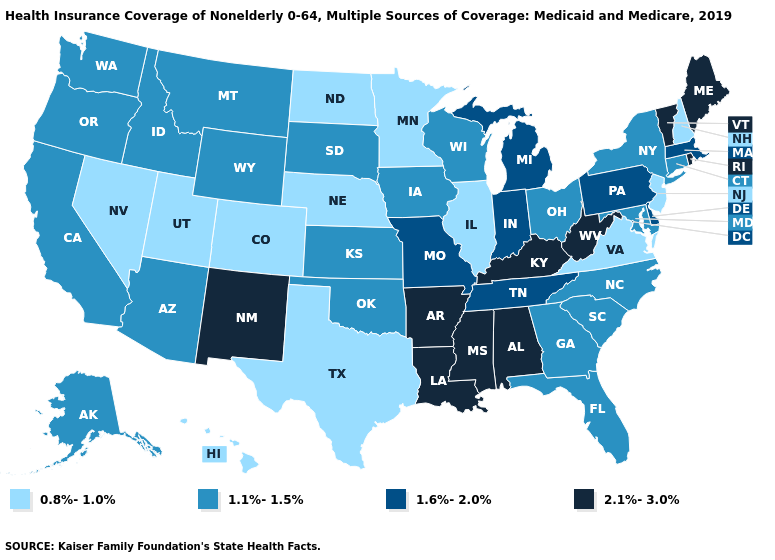What is the value of New Jersey?
Answer briefly. 0.8%-1.0%. Name the states that have a value in the range 0.8%-1.0%?
Keep it brief. Colorado, Hawaii, Illinois, Minnesota, Nebraska, Nevada, New Hampshire, New Jersey, North Dakota, Texas, Utah, Virginia. Does the map have missing data?
Quick response, please. No. Which states have the lowest value in the USA?
Answer briefly. Colorado, Hawaii, Illinois, Minnesota, Nebraska, Nevada, New Hampshire, New Jersey, North Dakota, Texas, Utah, Virginia. Does Missouri have a lower value than Texas?
Concise answer only. No. What is the value of New York?
Quick response, please. 1.1%-1.5%. Does Iowa have the highest value in the MidWest?
Concise answer only. No. Among the states that border Louisiana , which have the highest value?
Short answer required. Arkansas, Mississippi. Does South Dakota have the highest value in the MidWest?
Be succinct. No. Name the states that have a value in the range 1.1%-1.5%?
Answer briefly. Alaska, Arizona, California, Connecticut, Florida, Georgia, Idaho, Iowa, Kansas, Maryland, Montana, New York, North Carolina, Ohio, Oklahoma, Oregon, South Carolina, South Dakota, Washington, Wisconsin, Wyoming. How many symbols are there in the legend?
Write a very short answer. 4. What is the value of Missouri?
Answer briefly. 1.6%-2.0%. What is the value of South Carolina?
Quick response, please. 1.1%-1.5%. Which states have the lowest value in the South?
Quick response, please. Texas, Virginia. 